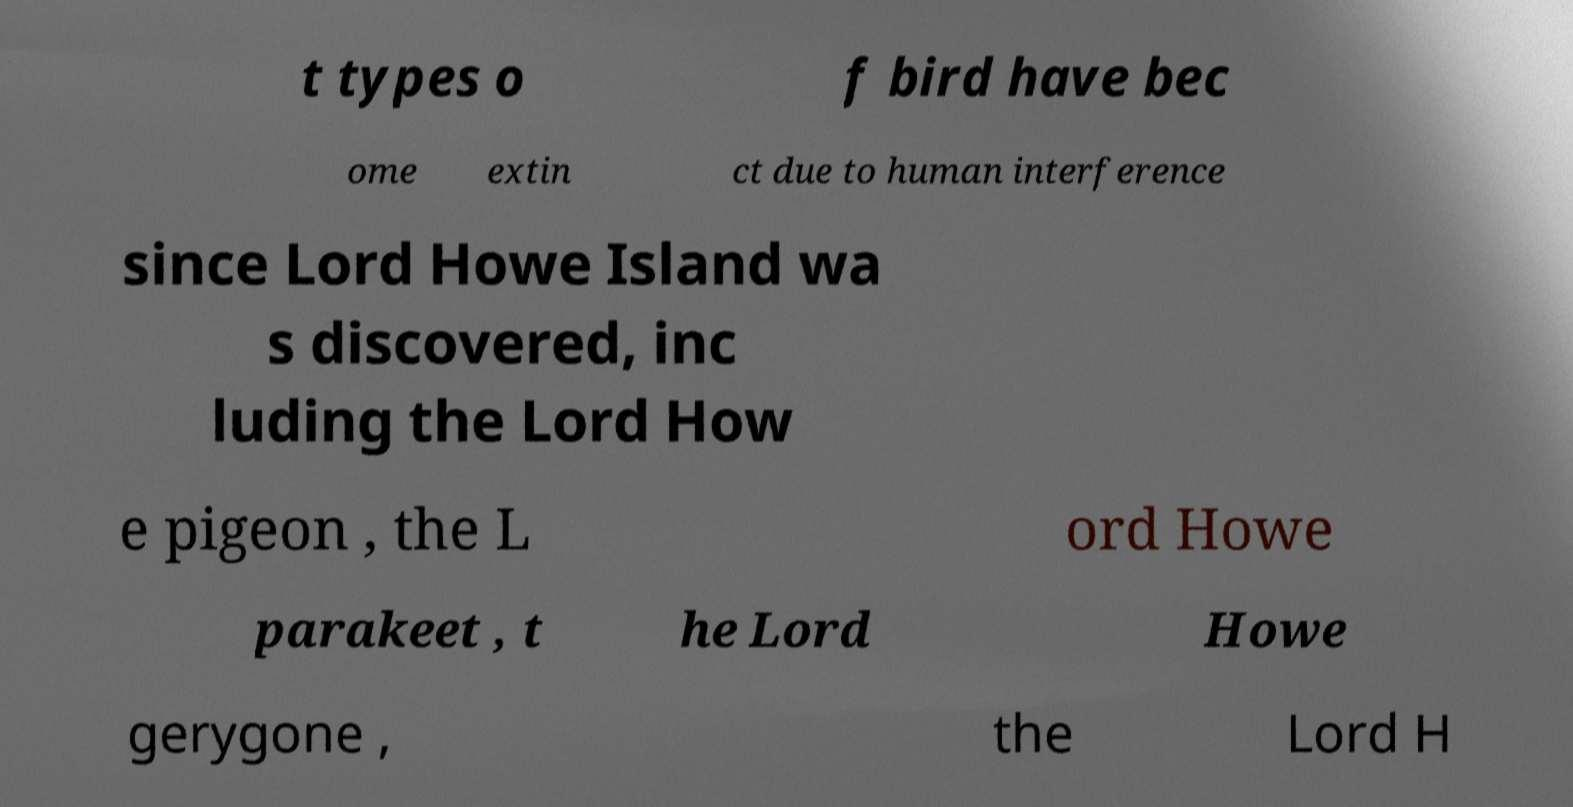There's text embedded in this image that I need extracted. Can you transcribe it verbatim? t types o f bird have bec ome extin ct due to human interference since Lord Howe Island wa s discovered, inc luding the Lord How e pigeon , the L ord Howe parakeet , t he Lord Howe gerygone , the Lord H 